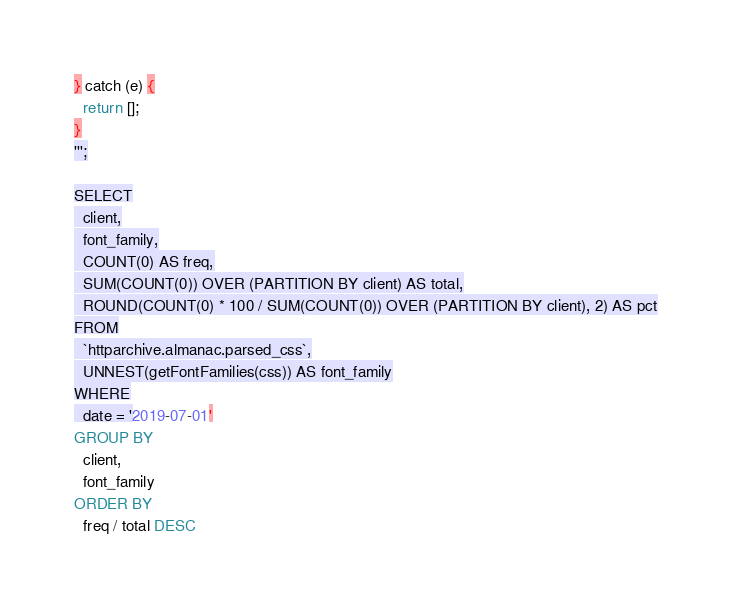Convert code to text. <code><loc_0><loc_0><loc_500><loc_500><_SQL_>} catch (e) {
  return [];
}
''';

SELECT
  client,
  font_family,
  COUNT(0) AS freq,
  SUM(COUNT(0)) OVER (PARTITION BY client) AS total,
  ROUND(COUNT(0) * 100 / SUM(COUNT(0)) OVER (PARTITION BY client), 2) AS pct
FROM
  `httparchive.almanac.parsed_css`,
  UNNEST(getFontFamilies(css)) AS font_family
WHERE
  date = '2019-07-01'
GROUP BY
  client,
  font_family
ORDER BY
  freq / total DESC
</code> 